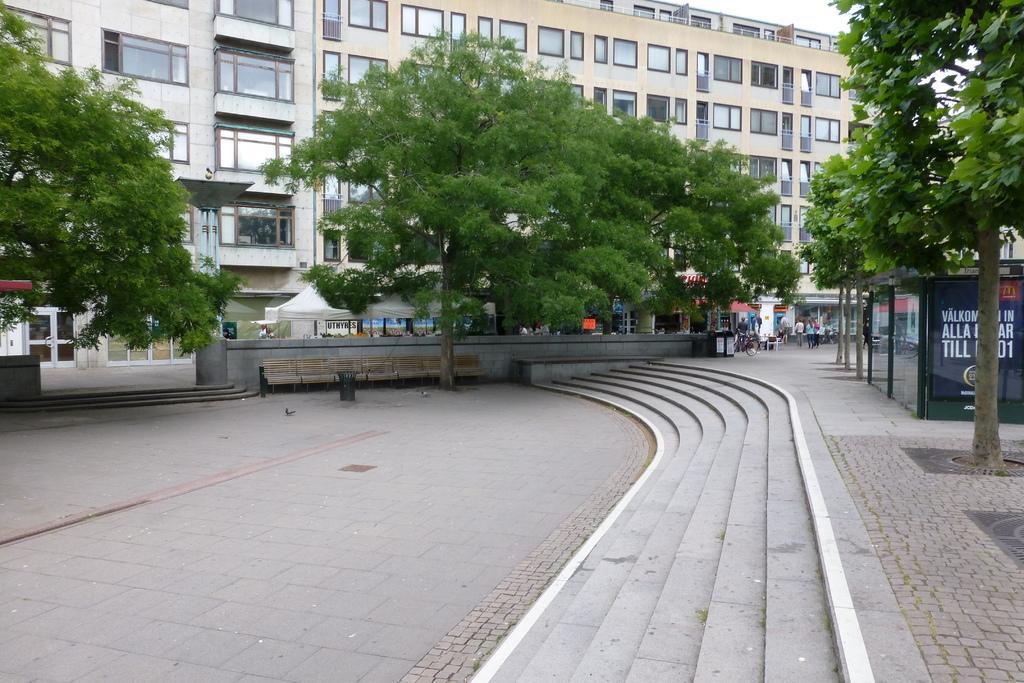Can you describe this image briefly? In this image I can see the ground, few stairs, few trees which are green in color, few persons standing, a bicycle and buildings. I can see few windows of the buildings and in the background I can see the sky. 